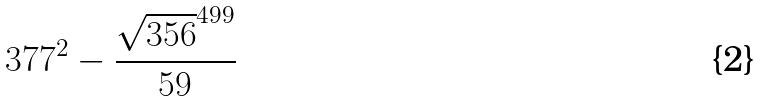<formula> <loc_0><loc_0><loc_500><loc_500>3 7 7 ^ { 2 } - \frac { \sqrt { 3 5 6 } ^ { 4 9 9 } } { 5 9 }</formula> 